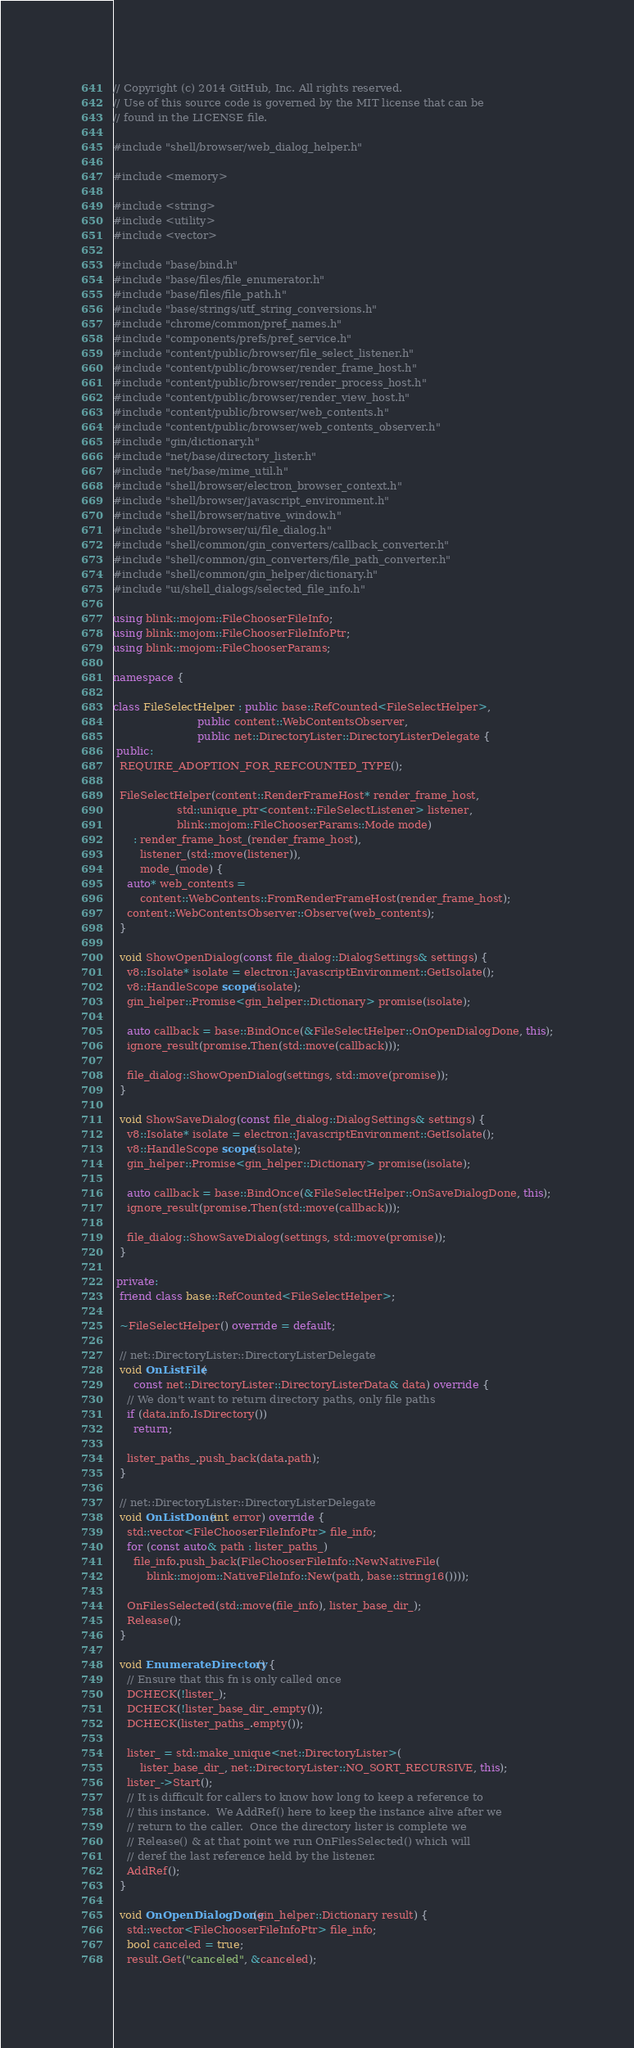<code> <loc_0><loc_0><loc_500><loc_500><_C++_>// Copyright (c) 2014 GitHub, Inc. All rights reserved.
// Use of this source code is governed by the MIT license that can be
// found in the LICENSE file.

#include "shell/browser/web_dialog_helper.h"

#include <memory>

#include <string>
#include <utility>
#include <vector>

#include "base/bind.h"
#include "base/files/file_enumerator.h"
#include "base/files/file_path.h"
#include "base/strings/utf_string_conversions.h"
#include "chrome/common/pref_names.h"
#include "components/prefs/pref_service.h"
#include "content/public/browser/file_select_listener.h"
#include "content/public/browser/render_frame_host.h"
#include "content/public/browser/render_process_host.h"
#include "content/public/browser/render_view_host.h"
#include "content/public/browser/web_contents.h"
#include "content/public/browser/web_contents_observer.h"
#include "gin/dictionary.h"
#include "net/base/directory_lister.h"
#include "net/base/mime_util.h"
#include "shell/browser/electron_browser_context.h"
#include "shell/browser/javascript_environment.h"
#include "shell/browser/native_window.h"
#include "shell/browser/ui/file_dialog.h"
#include "shell/common/gin_converters/callback_converter.h"
#include "shell/common/gin_converters/file_path_converter.h"
#include "shell/common/gin_helper/dictionary.h"
#include "ui/shell_dialogs/selected_file_info.h"

using blink::mojom::FileChooserFileInfo;
using blink::mojom::FileChooserFileInfoPtr;
using blink::mojom::FileChooserParams;

namespace {

class FileSelectHelper : public base::RefCounted<FileSelectHelper>,
                         public content::WebContentsObserver,
                         public net::DirectoryLister::DirectoryListerDelegate {
 public:
  REQUIRE_ADOPTION_FOR_REFCOUNTED_TYPE();

  FileSelectHelper(content::RenderFrameHost* render_frame_host,
                   std::unique_ptr<content::FileSelectListener> listener,
                   blink::mojom::FileChooserParams::Mode mode)
      : render_frame_host_(render_frame_host),
        listener_(std::move(listener)),
        mode_(mode) {
    auto* web_contents =
        content::WebContents::FromRenderFrameHost(render_frame_host);
    content::WebContentsObserver::Observe(web_contents);
  }

  void ShowOpenDialog(const file_dialog::DialogSettings& settings) {
    v8::Isolate* isolate = electron::JavascriptEnvironment::GetIsolate();
    v8::HandleScope scope(isolate);
    gin_helper::Promise<gin_helper::Dictionary> promise(isolate);

    auto callback = base::BindOnce(&FileSelectHelper::OnOpenDialogDone, this);
    ignore_result(promise.Then(std::move(callback)));

    file_dialog::ShowOpenDialog(settings, std::move(promise));
  }

  void ShowSaveDialog(const file_dialog::DialogSettings& settings) {
    v8::Isolate* isolate = electron::JavascriptEnvironment::GetIsolate();
    v8::HandleScope scope(isolate);
    gin_helper::Promise<gin_helper::Dictionary> promise(isolate);

    auto callback = base::BindOnce(&FileSelectHelper::OnSaveDialogDone, this);
    ignore_result(promise.Then(std::move(callback)));

    file_dialog::ShowSaveDialog(settings, std::move(promise));
  }

 private:
  friend class base::RefCounted<FileSelectHelper>;

  ~FileSelectHelper() override = default;

  // net::DirectoryLister::DirectoryListerDelegate
  void OnListFile(
      const net::DirectoryLister::DirectoryListerData& data) override {
    // We don't want to return directory paths, only file paths
    if (data.info.IsDirectory())
      return;

    lister_paths_.push_back(data.path);
  }

  // net::DirectoryLister::DirectoryListerDelegate
  void OnListDone(int error) override {
    std::vector<FileChooserFileInfoPtr> file_info;
    for (const auto& path : lister_paths_)
      file_info.push_back(FileChooserFileInfo::NewNativeFile(
          blink::mojom::NativeFileInfo::New(path, base::string16())));

    OnFilesSelected(std::move(file_info), lister_base_dir_);
    Release();
  }

  void EnumerateDirectory() {
    // Ensure that this fn is only called once
    DCHECK(!lister_);
    DCHECK(!lister_base_dir_.empty());
    DCHECK(lister_paths_.empty());

    lister_ = std::make_unique<net::DirectoryLister>(
        lister_base_dir_, net::DirectoryLister::NO_SORT_RECURSIVE, this);
    lister_->Start();
    // It is difficult for callers to know how long to keep a reference to
    // this instance.  We AddRef() here to keep the instance alive after we
    // return to the caller.  Once the directory lister is complete we
    // Release() & at that point we run OnFilesSelected() which will
    // deref the last reference held by the listener.
    AddRef();
  }

  void OnOpenDialogDone(gin_helper::Dictionary result) {
    std::vector<FileChooserFileInfoPtr> file_info;
    bool canceled = true;
    result.Get("canceled", &canceled);</code> 